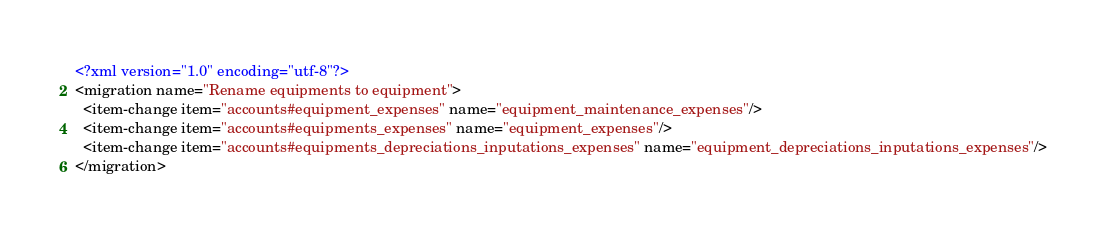Convert code to text. <code><loc_0><loc_0><loc_500><loc_500><_XML_><?xml version="1.0" encoding="utf-8"?>
<migration name="Rename equipments to equipment">
  <item-change item="accounts#equipment_expenses" name="equipment_maintenance_expenses"/>
  <item-change item="accounts#equipments_expenses" name="equipment_expenses"/>
  <item-change item="accounts#equipments_depreciations_inputations_expenses" name="equipment_depreciations_inputations_expenses"/>
</migration>
</code> 